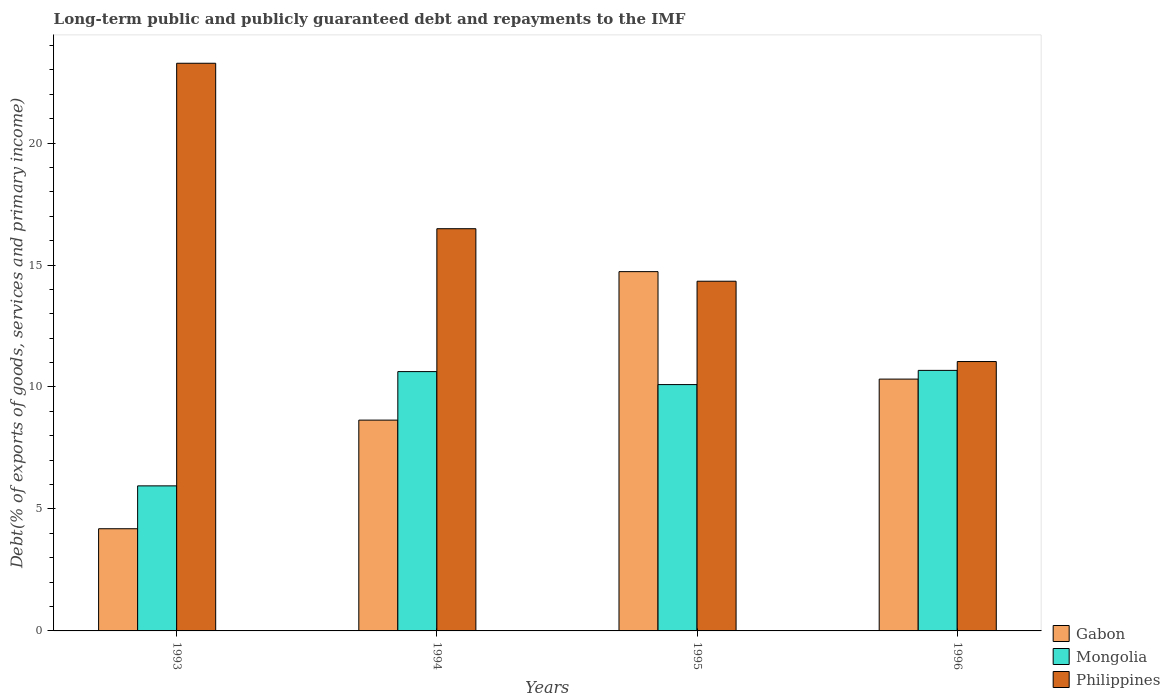How many different coloured bars are there?
Ensure brevity in your answer.  3. How many groups of bars are there?
Keep it short and to the point. 4. Are the number of bars on each tick of the X-axis equal?
Your answer should be compact. Yes. How many bars are there on the 2nd tick from the right?
Your answer should be very brief. 3. What is the label of the 1st group of bars from the left?
Your answer should be very brief. 1993. What is the debt and repayments in Mongolia in 1993?
Your response must be concise. 5.95. Across all years, what is the maximum debt and repayments in Philippines?
Ensure brevity in your answer.  23.27. Across all years, what is the minimum debt and repayments in Philippines?
Keep it short and to the point. 11.04. In which year was the debt and repayments in Gabon maximum?
Your response must be concise. 1995. What is the total debt and repayments in Gabon in the graph?
Your answer should be compact. 37.88. What is the difference between the debt and repayments in Gabon in 1993 and that in 1994?
Your answer should be compact. -4.45. What is the difference between the debt and repayments in Mongolia in 1996 and the debt and repayments in Gabon in 1994?
Provide a short and direct response. 2.04. What is the average debt and repayments in Gabon per year?
Ensure brevity in your answer.  9.47. In the year 1995, what is the difference between the debt and repayments in Philippines and debt and repayments in Mongolia?
Give a very brief answer. 4.24. In how many years, is the debt and repayments in Gabon greater than 17 %?
Make the answer very short. 0. What is the ratio of the debt and repayments in Gabon in 1993 to that in 1996?
Your answer should be very brief. 0.41. Is the difference between the debt and repayments in Philippines in 1994 and 1996 greater than the difference between the debt and repayments in Mongolia in 1994 and 1996?
Offer a very short reply. Yes. What is the difference between the highest and the second highest debt and repayments in Mongolia?
Make the answer very short. 0.05. What is the difference between the highest and the lowest debt and repayments in Gabon?
Your response must be concise. 10.54. What does the 2nd bar from the left in 1993 represents?
Your answer should be very brief. Mongolia. What does the 3rd bar from the right in 1993 represents?
Offer a terse response. Gabon. Is it the case that in every year, the sum of the debt and repayments in Gabon and debt and repayments in Mongolia is greater than the debt and repayments in Philippines?
Ensure brevity in your answer.  No. Are all the bars in the graph horizontal?
Your response must be concise. No. How many years are there in the graph?
Your answer should be compact. 4. Does the graph contain grids?
Give a very brief answer. No. Where does the legend appear in the graph?
Your response must be concise. Bottom right. How many legend labels are there?
Your response must be concise. 3. What is the title of the graph?
Offer a very short reply. Long-term public and publicly guaranteed debt and repayments to the IMF. Does "Iraq" appear as one of the legend labels in the graph?
Give a very brief answer. No. What is the label or title of the X-axis?
Provide a succinct answer. Years. What is the label or title of the Y-axis?
Offer a terse response. Debt(% of exports of goods, services and primary income). What is the Debt(% of exports of goods, services and primary income) of Gabon in 1993?
Your answer should be very brief. 4.19. What is the Debt(% of exports of goods, services and primary income) in Mongolia in 1993?
Make the answer very short. 5.95. What is the Debt(% of exports of goods, services and primary income) in Philippines in 1993?
Give a very brief answer. 23.27. What is the Debt(% of exports of goods, services and primary income) in Gabon in 1994?
Offer a very short reply. 8.64. What is the Debt(% of exports of goods, services and primary income) in Mongolia in 1994?
Offer a terse response. 10.63. What is the Debt(% of exports of goods, services and primary income) in Philippines in 1994?
Make the answer very short. 16.49. What is the Debt(% of exports of goods, services and primary income) in Gabon in 1995?
Provide a succinct answer. 14.73. What is the Debt(% of exports of goods, services and primary income) of Mongolia in 1995?
Give a very brief answer. 10.1. What is the Debt(% of exports of goods, services and primary income) in Philippines in 1995?
Your answer should be very brief. 14.34. What is the Debt(% of exports of goods, services and primary income) of Gabon in 1996?
Your answer should be very brief. 10.32. What is the Debt(% of exports of goods, services and primary income) in Mongolia in 1996?
Offer a very short reply. 10.68. What is the Debt(% of exports of goods, services and primary income) in Philippines in 1996?
Give a very brief answer. 11.04. Across all years, what is the maximum Debt(% of exports of goods, services and primary income) in Gabon?
Offer a terse response. 14.73. Across all years, what is the maximum Debt(% of exports of goods, services and primary income) in Mongolia?
Provide a succinct answer. 10.68. Across all years, what is the maximum Debt(% of exports of goods, services and primary income) of Philippines?
Your response must be concise. 23.27. Across all years, what is the minimum Debt(% of exports of goods, services and primary income) in Gabon?
Give a very brief answer. 4.19. Across all years, what is the minimum Debt(% of exports of goods, services and primary income) of Mongolia?
Your response must be concise. 5.95. Across all years, what is the minimum Debt(% of exports of goods, services and primary income) in Philippines?
Provide a succinct answer. 11.04. What is the total Debt(% of exports of goods, services and primary income) in Gabon in the graph?
Keep it short and to the point. 37.88. What is the total Debt(% of exports of goods, services and primary income) in Mongolia in the graph?
Give a very brief answer. 37.36. What is the total Debt(% of exports of goods, services and primary income) of Philippines in the graph?
Keep it short and to the point. 65.14. What is the difference between the Debt(% of exports of goods, services and primary income) of Gabon in 1993 and that in 1994?
Your answer should be very brief. -4.45. What is the difference between the Debt(% of exports of goods, services and primary income) in Mongolia in 1993 and that in 1994?
Give a very brief answer. -4.68. What is the difference between the Debt(% of exports of goods, services and primary income) in Philippines in 1993 and that in 1994?
Your response must be concise. 6.78. What is the difference between the Debt(% of exports of goods, services and primary income) of Gabon in 1993 and that in 1995?
Your answer should be very brief. -10.54. What is the difference between the Debt(% of exports of goods, services and primary income) of Mongolia in 1993 and that in 1995?
Your answer should be compact. -4.15. What is the difference between the Debt(% of exports of goods, services and primary income) in Philippines in 1993 and that in 1995?
Give a very brief answer. 8.94. What is the difference between the Debt(% of exports of goods, services and primary income) in Gabon in 1993 and that in 1996?
Ensure brevity in your answer.  -6.13. What is the difference between the Debt(% of exports of goods, services and primary income) in Mongolia in 1993 and that in 1996?
Ensure brevity in your answer.  -4.73. What is the difference between the Debt(% of exports of goods, services and primary income) of Philippines in 1993 and that in 1996?
Provide a succinct answer. 12.23. What is the difference between the Debt(% of exports of goods, services and primary income) in Gabon in 1994 and that in 1995?
Your answer should be compact. -6.09. What is the difference between the Debt(% of exports of goods, services and primary income) in Mongolia in 1994 and that in 1995?
Offer a very short reply. 0.53. What is the difference between the Debt(% of exports of goods, services and primary income) in Philippines in 1994 and that in 1995?
Give a very brief answer. 2.15. What is the difference between the Debt(% of exports of goods, services and primary income) in Gabon in 1994 and that in 1996?
Your answer should be very brief. -1.68. What is the difference between the Debt(% of exports of goods, services and primary income) in Mongolia in 1994 and that in 1996?
Offer a very short reply. -0.05. What is the difference between the Debt(% of exports of goods, services and primary income) in Philippines in 1994 and that in 1996?
Give a very brief answer. 5.45. What is the difference between the Debt(% of exports of goods, services and primary income) in Gabon in 1995 and that in 1996?
Your answer should be compact. 4.41. What is the difference between the Debt(% of exports of goods, services and primary income) in Mongolia in 1995 and that in 1996?
Your answer should be very brief. -0.58. What is the difference between the Debt(% of exports of goods, services and primary income) in Philippines in 1995 and that in 1996?
Give a very brief answer. 3.29. What is the difference between the Debt(% of exports of goods, services and primary income) in Gabon in 1993 and the Debt(% of exports of goods, services and primary income) in Mongolia in 1994?
Your response must be concise. -6.44. What is the difference between the Debt(% of exports of goods, services and primary income) in Gabon in 1993 and the Debt(% of exports of goods, services and primary income) in Philippines in 1994?
Ensure brevity in your answer.  -12.3. What is the difference between the Debt(% of exports of goods, services and primary income) of Mongolia in 1993 and the Debt(% of exports of goods, services and primary income) of Philippines in 1994?
Give a very brief answer. -10.54. What is the difference between the Debt(% of exports of goods, services and primary income) of Gabon in 1993 and the Debt(% of exports of goods, services and primary income) of Mongolia in 1995?
Make the answer very short. -5.91. What is the difference between the Debt(% of exports of goods, services and primary income) in Gabon in 1993 and the Debt(% of exports of goods, services and primary income) in Philippines in 1995?
Your answer should be very brief. -10.15. What is the difference between the Debt(% of exports of goods, services and primary income) of Mongolia in 1993 and the Debt(% of exports of goods, services and primary income) of Philippines in 1995?
Give a very brief answer. -8.39. What is the difference between the Debt(% of exports of goods, services and primary income) in Gabon in 1993 and the Debt(% of exports of goods, services and primary income) in Mongolia in 1996?
Offer a very short reply. -6.49. What is the difference between the Debt(% of exports of goods, services and primary income) in Gabon in 1993 and the Debt(% of exports of goods, services and primary income) in Philippines in 1996?
Provide a short and direct response. -6.85. What is the difference between the Debt(% of exports of goods, services and primary income) in Mongolia in 1993 and the Debt(% of exports of goods, services and primary income) in Philippines in 1996?
Provide a succinct answer. -5.1. What is the difference between the Debt(% of exports of goods, services and primary income) in Gabon in 1994 and the Debt(% of exports of goods, services and primary income) in Mongolia in 1995?
Keep it short and to the point. -1.46. What is the difference between the Debt(% of exports of goods, services and primary income) of Gabon in 1994 and the Debt(% of exports of goods, services and primary income) of Philippines in 1995?
Provide a succinct answer. -5.69. What is the difference between the Debt(% of exports of goods, services and primary income) of Mongolia in 1994 and the Debt(% of exports of goods, services and primary income) of Philippines in 1995?
Give a very brief answer. -3.7. What is the difference between the Debt(% of exports of goods, services and primary income) of Gabon in 1994 and the Debt(% of exports of goods, services and primary income) of Mongolia in 1996?
Make the answer very short. -2.04. What is the difference between the Debt(% of exports of goods, services and primary income) in Gabon in 1994 and the Debt(% of exports of goods, services and primary income) in Philippines in 1996?
Keep it short and to the point. -2.4. What is the difference between the Debt(% of exports of goods, services and primary income) in Mongolia in 1994 and the Debt(% of exports of goods, services and primary income) in Philippines in 1996?
Give a very brief answer. -0.41. What is the difference between the Debt(% of exports of goods, services and primary income) in Gabon in 1995 and the Debt(% of exports of goods, services and primary income) in Mongolia in 1996?
Make the answer very short. 4.05. What is the difference between the Debt(% of exports of goods, services and primary income) of Gabon in 1995 and the Debt(% of exports of goods, services and primary income) of Philippines in 1996?
Offer a very short reply. 3.69. What is the difference between the Debt(% of exports of goods, services and primary income) of Mongolia in 1995 and the Debt(% of exports of goods, services and primary income) of Philippines in 1996?
Offer a terse response. -0.94. What is the average Debt(% of exports of goods, services and primary income) of Gabon per year?
Give a very brief answer. 9.47. What is the average Debt(% of exports of goods, services and primary income) of Mongolia per year?
Provide a short and direct response. 9.34. What is the average Debt(% of exports of goods, services and primary income) in Philippines per year?
Keep it short and to the point. 16.29. In the year 1993, what is the difference between the Debt(% of exports of goods, services and primary income) in Gabon and Debt(% of exports of goods, services and primary income) in Mongolia?
Give a very brief answer. -1.76. In the year 1993, what is the difference between the Debt(% of exports of goods, services and primary income) in Gabon and Debt(% of exports of goods, services and primary income) in Philippines?
Offer a terse response. -19.08. In the year 1993, what is the difference between the Debt(% of exports of goods, services and primary income) of Mongolia and Debt(% of exports of goods, services and primary income) of Philippines?
Provide a short and direct response. -17.33. In the year 1994, what is the difference between the Debt(% of exports of goods, services and primary income) of Gabon and Debt(% of exports of goods, services and primary income) of Mongolia?
Give a very brief answer. -1.99. In the year 1994, what is the difference between the Debt(% of exports of goods, services and primary income) in Gabon and Debt(% of exports of goods, services and primary income) in Philippines?
Keep it short and to the point. -7.85. In the year 1994, what is the difference between the Debt(% of exports of goods, services and primary income) in Mongolia and Debt(% of exports of goods, services and primary income) in Philippines?
Offer a very short reply. -5.86. In the year 1995, what is the difference between the Debt(% of exports of goods, services and primary income) in Gabon and Debt(% of exports of goods, services and primary income) in Mongolia?
Provide a succinct answer. 4.63. In the year 1995, what is the difference between the Debt(% of exports of goods, services and primary income) in Gabon and Debt(% of exports of goods, services and primary income) in Philippines?
Provide a short and direct response. 0.39. In the year 1995, what is the difference between the Debt(% of exports of goods, services and primary income) of Mongolia and Debt(% of exports of goods, services and primary income) of Philippines?
Your answer should be very brief. -4.24. In the year 1996, what is the difference between the Debt(% of exports of goods, services and primary income) in Gabon and Debt(% of exports of goods, services and primary income) in Mongolia?
Provide a succinct answer. -0.36. In the year 1996, what is the difference between the Debt(% of exports of goods, services and primary income) in Gabon and Debt(% of exports of goods, services and primary income) in Philippines?
Give a very brief answer. -0.72. In the year 1996, what is the difference between the Debt(% of exports of goods, services and primary income) of Mongolia and Debt(% of exports of goods, services and primary income) of Philippines?
Provide a succinct answer. -0.36. What is the ratio of the Debt(% of exports of goods, services and primary income) in Gabon in 1993 to that in 1994?
Your response must be concise. 0.48. What is the ratio of the Debt(% of exports of goods, services and primary income) in Mongolia in 1993 to that in 1994?
Give a very brief answer. 0.56. What is the ratio of the Debt(% of exports of goods, services and primary income) of Philippines in 1993 to that in 1994?
Offer a very short reply. 1.41. What is the ratio of the Debt(% of exports of goods, services and primary income) in Gabon in 1993 to that in 1995?
Provide a short and direct response. 0.28. What is the ratio of the Debt(% of exports of goods, services and primary income) in Mongolia in 1993 to that in 1995?
Your response must be concise. 0.59. What is the ratio of the Debt(% of exports of goods, services and primary income) of Philippines in 1993 to that in 1995?
Your answer should be compact. 1.62. What is the ratio of the Debt(% of exports of goods, services and primary income) in Gabon in 1993 to that in 1996?
Ensure brevity in your answer.  0.41. What is the ratio of the Debt(% of exports of goods, services and primary income) of Mongolia in 1993 to that in 1996?
Provide a short and direct response. 0.56. What is the ratio of the Debt(% of exports of goods, services and primary income) in Philippines in 1993 to that in 1996?
Provide a short and direct response. 2.11. What is the ratio of the Debt(% of exports of goods, services and primary income) in Gabon in 1994 to that in 1995?
Offer a terse response. 0.59. What is the ratio of the Debt(% of exports of goods, services and primary income) of Mongolia in 1994 to that in 1995?
Your answer should be very brief. 1.05. What is the ratio of the Debt(% of exports of goods, services and primary income) in Philippines in 1994 to that in 1995?
Offer a very short reply. 1.15. What is the ratio of the Debt(% of exports of goods, services and primary income) of Gabon in 1994 to that in 1996?
Give a very brief answer. 0.84. What is the ratio of the Debt(% of exports of goods, services and primary income) of Philippines in 1994 to that in 1996?
Your response must be concise. 1.49. What is the ratio of the Debt(% of exports of goods, services and primary income) of Gabon in 1995 to that in 1996?
Make the answer very short. 1.43. What is the ratio of the Debt(% of exports of goods, services and primary income) in Mongolia in 1995 to that in 1996?
Provide a succinct answer. 0.95. What is the ratio of the Debt(% of exports of goods, services and primary income) in Philippines in 1995 to that in 1996?
Your response must be concise. 1.3. What is the difference between the highest and the second highest Debt(% of exports of goods, services and primary income) in Gabon?
Your response must be concise. 4.41. What is the difference between the highest and the second highest Debt(% of exports of goods, services and primary income) in Mongolia?
Your response must be concise. 0.05. What is the difference between the highest and the second highest Debt(% of exports of goods, services and primary income) of Philippines?
Offer a very short reply. 6.78. What is the difference between the highest and the lowest Debt(% of exports of goods, services and primary income) in Gabon?
Give a very brief answer. 10.54. What is the difference between the highest and the lowest Debt(% of exports of goods, services and primary income) in Mongolia?
Your answer should be very brief. 4.73. What is the difference between the highest and the lowest Debt(% of exports of goods, services and primary income) in Philippines?
Your answer should be compact. 12.23. 